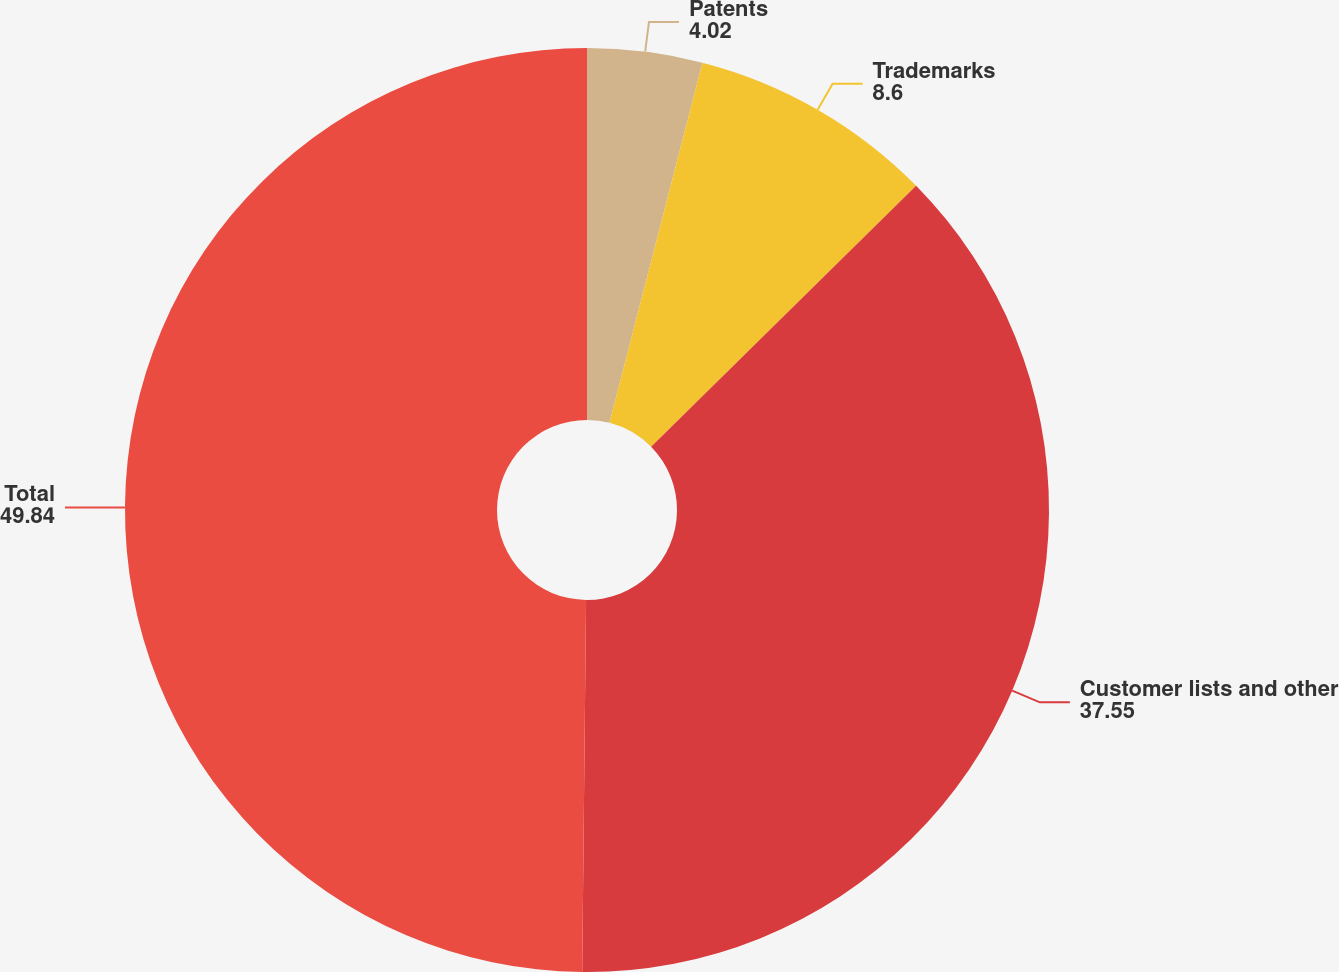Convert chart to OTSL. <chart><loc_0><loc_0><loc_500><loc_500><pie_chart><fcel>Patents<fcel>Trademarks<fcel>Customer lists and other<fcel>Total<nl><fcel>4.02%<fcel>8.6%<fcel>37.55%<fcel>49.84%<nl></chart> 